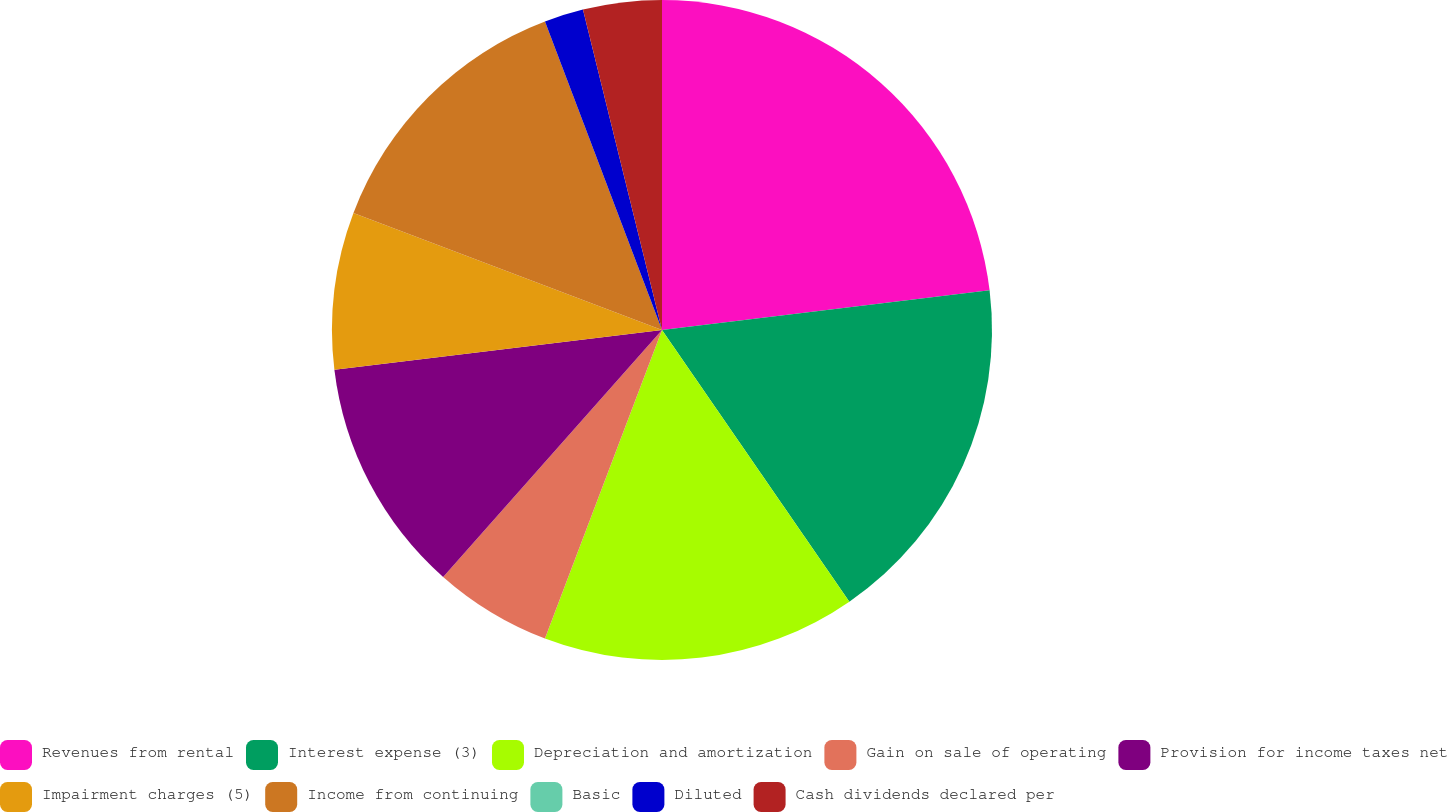Convert chart. <chart><loc_0><loc_0><loc_500><loc_500><pie_chart><fcel>Revenues from rental<fcel>Interest expense (3)<fcel>Depreciation and amortization<fcel>Gain on sale of operating<fcel>Provision for income taxes net<fcel>Impairment charges (5)<fcel>Income from continuing<fcel>Basic<fcel>Diluted<fcel>Cash dividends declared per<nl><fcel>23.08%<fcel>17.31%<fcel>15.38%<fcel>5.77%<fcel>11.54%<fcel>7.69%<fcel>13.46%<fcel>0.0%<fcel>1.92%<fcel>3.85%<nl></chart> 